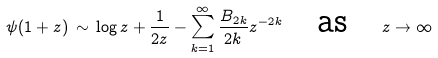Convert formula to latex. <formula><loc_0><loc_0><loc_500><loc_500>\psi ( 1 + z ) \, \sim \, \log z + \frac { 1 } { 2 z } - \sum ^ { \infty } _ { k = 1 } \frac { B _ { 2 k } } { 2 k } z ^ { - 2 k } \quad \text {as} \quad z \to \infty</formula> 